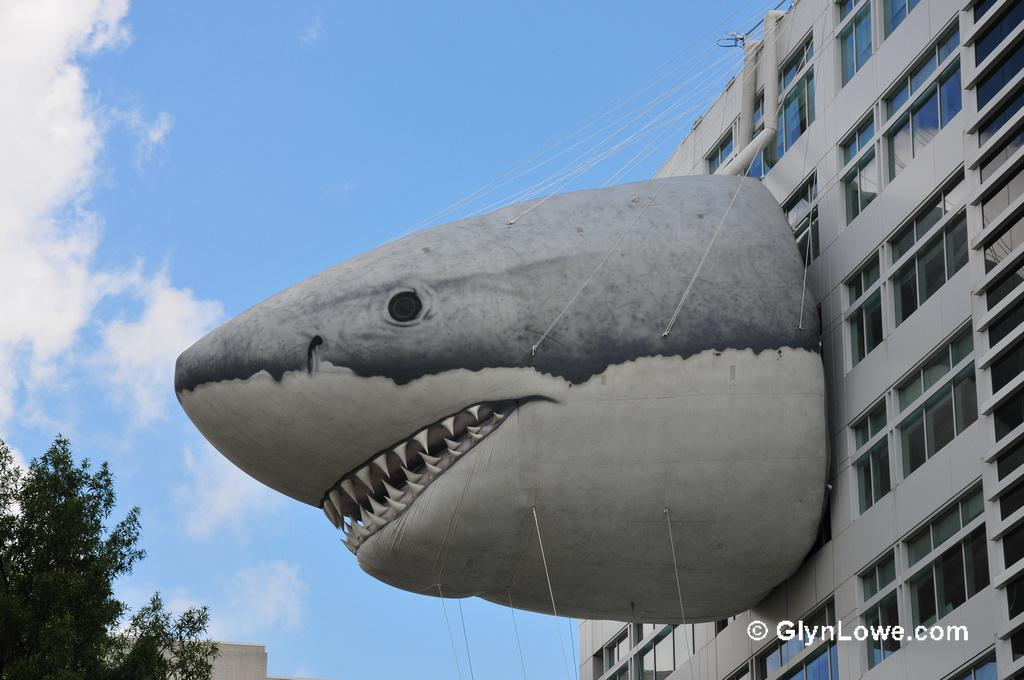What structure is the main subject of the image? There is a building in the image. What can be seen in the background of the image? There are clouds, a tree, and the sky visible in the background of the image. How many cows are grazing in front of the building in the image? There are no cows present in the image; the focus is on the building and the background elements. 